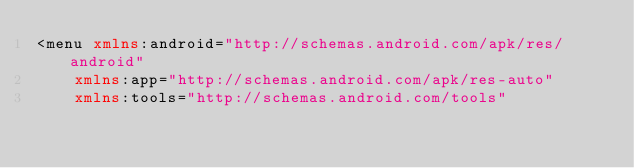<code> <loc_0><loc_0><loc_500><loc_500><_XML_><menu xmlns:android="http://schemas.android.com/apk/res/android"
    xmlns:app="http://schemas.android.com/apk/res-auto"
    xmlns:tools="http://schemas.android.com/tools"</code> 